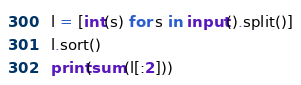Convert code to text. <code><loc_0><loc_0><loc_500><loc_500><_Python_>l = [int(s) for s in input().split()]
l.sort()
print(sum(l[:2]))
</code> 